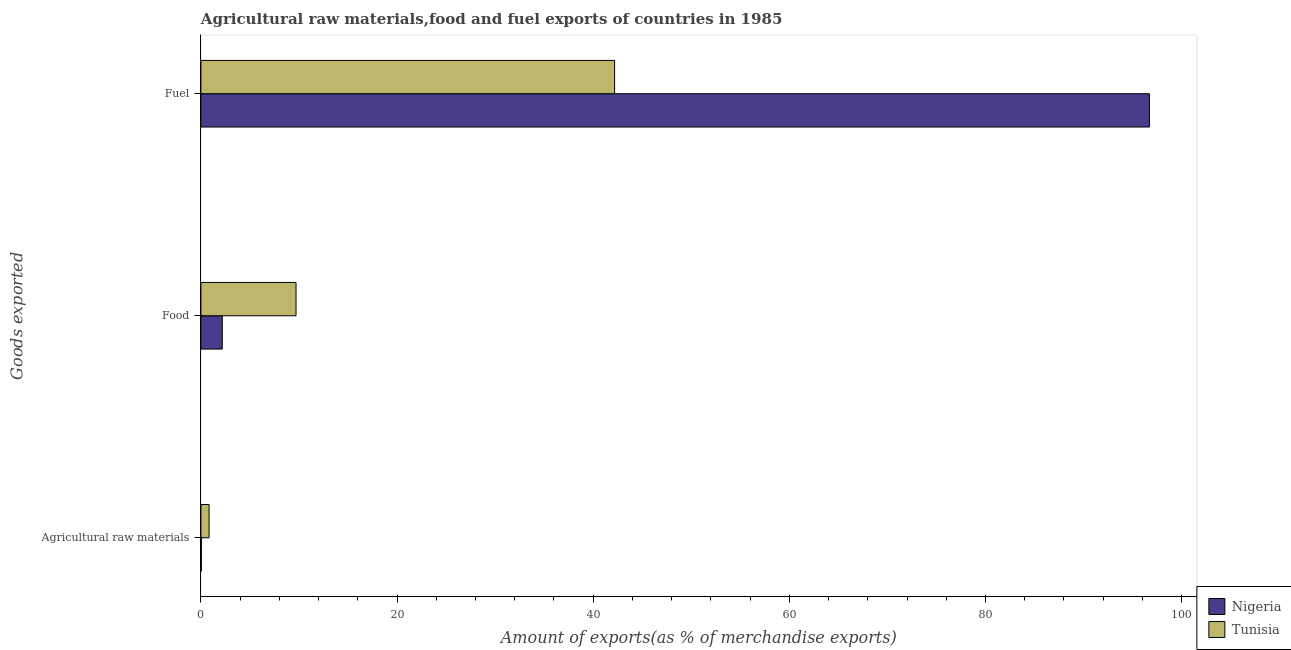How many groups of bars are there?
Your answer should be very brief. 3. How many bars are there on the 2nd tick from the top?
Your answer should be very brief. 2. How many bars are there on the 3rd tick from the bottom?
Provide a short and direct response. 2. What is the label of the 2nd group of bars from the top?
Provide a succinct answer. Food. What is the percentage of fuel exports in Nigeria?
Offer a terse response. 96.72. Across all countries, what is the maximum percentage of raw materials exports?
Offer a very short reply. 0.83. Across all countries, what is the minimum percentage of raw materials exports?
Offer a terse response. 0.04. In which country was the percentage of fuel exports maximum?
Your answer should be very brief. Nigeria. In which country was the percentage of food exports minimum?
Provide a succinct answer. Nigeria. What is the total percentage of food exports in the graph?
Offer a terse response. 11.88. What is the difference between the percentage of food exports in Tunisia and that in Nigeria?
Offer a terse response. 7.52. What is the difference between the percentage of fuel exports in Nigeria and the percentage of raw materials exports in Tunisia?
Provide a short and direct response. 95.89. What is the average percentage of food exports per country?
Your answer should be compact. 5.94. What is the difference between the percentage of raw materials exports and percentage of food exports in Nigeria?
Your answer should be very brief. -2.13. What is the ratio of the percentage of fuel exports in Tunisia to that in Nigeria?
Provide a succinct answer. 0.44. What is the difference between the highest and the second highest percentage of fuel exports?
Provide a succinct answer. 54.53. What is the difference between the highest and the lowest percentage of raw materials exports?
Your answer should be compact. 0.79. In how many countries, is the percentage of food exports greater than the average percentage of food exports taken over all countries?
Your answer should be very brief. 1. Is the sum of the percentage of raw materials exports in Nigeria and Tunisia greater than the maximum percentage of food exports across all countries?
Keep it short and to the point. No. What does the 1st bar from the top in Agricultural raw materials represents?
Ensure brevity in your answer.  Tunisia. What does the 2nd bar from the bottom in Fuel represents?
Ensure brevity in your answer.  Tunisia. Is it the case that in every country, the sum of the percentage of raw materials exports and percentage of food exports is greater than the percentage of fuel exports?
Your answer should be very brief. No. Does the graph contain any zero values?
Your answer should be very brief. No. Does the graph contain grids?
Your response must be concise. No. How many legend labels are there?
Your answer should be compact. 2. How are the legend labels stacked?
Keep it short and to the point. Vertical. What is the title of the graph?
Keep it short and to the point. Agricultural raw materials,food and fuel exports of countries in 1985. What is the label or title of the X-axis?
Keep it short and to the point. Amount of exports(as % of merchandise exports). What is the label or title of the Y-axis?
Provide a short and direct response. Goods exported. What is the Amount of exports(as % of merchandise exports) in Nigeria in Agricultural raw materials?
Give a very brief answer. 0.04. What is the Amount of exports(as % of merchandise exports) of Tunisia in Agricultural raw materials?
Give a very brief answer. 0.83. What is the Amount of exports(as % of merchandise exports) in Nigeria in Food?
Make the answer very short. 2.18. What is the Amount of exports(as % of merchandise exports) in Tunisia in Food?
Your answer should be compact. 9.7. What is the Amount of exports(as % of merchandise exports) in Nigeria in Fuel?
Your answer should be very brief. 96.72. What is the Amount of exports(as % of merchandise exports) of Tunisia in Fuel?
Your answer should be compact. 42.18. Across all Goods exported, what is the maximum Amount of exports(as % of merchandise exports) of Nigeria?
Your answer should be very brief. 96.72. Across all Goods exported, what is the maximum Amount of exports(as % of merchandise exports) of Tunisia?
Your answer should be compact. 42.18. Across all Goods exported, what is the minimum Amount of exports(as % of merchandise exports) of Nigeria?
Ensure brevity in your answer.  0.04. Across all Goods exported, what is the minimum Amount of exports(as % of merchandise exports) in Tunisia?
Offer a very short reply. 0.83. What is the total Amount of exports(as % of merchandise exports) of Nigeria in the graph?
Provide a short and direct response. 98.94. What is the total Amount of exports(as % of merchandise exports) in Tunisia in the graph?
Offer a terse response. 52.71. What is the difference between the Amount of exports(as % of merchandise exports) of Nigeria in Agricultural raw materials and that in Food?
Provide a succinct answer. -2.13. What is the difference between the Amount of exports(as % of merchandise exports) of Tunisia in Agricultural raw materials and that in Food?
Offer a very short reply. -8.87. What is the difference between the Amount of exports(as % of merchandise exports) of Nigeria in Agricultural raw materials and that in Fuel?
Give a very brief answer. -96.67. What is the difference between the Amount of exports(as % of merchandise exports) of Tunisia in Agricultural raw materials and that in Fuel?
Keep it short and to the point. -41.35. What is the difference between the Amount of exports(as % of merchandise exports) in Nigeria in Food and that in Fuel?
Provide a succinct answer. -94.54. What is the difference between the Amount of exports(as % of merchandise exports) in Tunisia in Food and that in Fuel?
Your answer should be very brief. -32.48. What is the difference between the Amount of exports(as % of merchandise exports) of Nigeria in Agricultural raw materials and the Amount of exports(as % of merchandise exports) of Tunisia in Food?
Your answer should be compact. -9.65. What is the difference between the Amount of exports(as % of merchandise exports) of Nigeria in Agricultural raw materials and the Amount of exports(as % of merchandise exports) of Tunisia in Fuel?
Your response must be concise. -42.14. What is the difference between the Amount of exports(as % of merchandise exports) of Nigeria in Food and the Amount of exports(as % of merchandise exports) of Tunisia in Fuel?
Offer a terse response. -40.01. What is the average Amount of exports(as % of merchandise exports) of Nigeria per Goods exported?
Keep it short and to the point. 32.98. What is the average Amount of exports(as % of merchandise exports) of Tunisia per Goods exported?
Give a very brief answer. 17.57. What is the difference between the Amount of exports(as % of merchandise exports) of Nigeria and Amount of exports(as % of merchandise exports) of Tunisia in Agricultural raw materials?
Provide a short and direct response. -0.79. What is the difference between the Amount of exports(as % of merchandise exports) in Nigeria and Amount of exports(as % of merchandise exports) in Tunisia in Food?
Offer a very short reply. -7.52. What is the difference between the Amount of exports(as % of merchandise exports) in Nigeria and Amount of exports(as % of merchandise exports) in Tunisia in Fuel?
Ensure brevity in your answer.  54.53. What is the ratio of the Amount of exports(as % of merchandise exports) of Nigeria in Agricultural raw materials to that in Food?
Give a very brief answer. 0.02. What is the ratio of the Amount of exports(as % of merchandise exports) in Tunisia in Agricultural raw materials to that in Food?
Offer a very short reply. 0.09. What is the ratio of the Amount of exports(as % of merchandise exports) in Nigeria in Agricultural raw materials to that in Fuel?
Give a very brief answer. 0. What is the ratio of the Amount of exports(as % of merchandise exports) in Tunisia in Agricultural raw materials to that in Fuel?
Your answer should be compact. 0.02. What is the ratio of the Amount of exports(as % of merchandise exports) of Nigeria in Food to that in Fuel?
Offer a very short reply. 0.02. What is the ratio of the Amount of exports(as % of merchandise exports) in Tunisia in Food to that in Fuel?
Provide a succinct answer. 0.23. What is the difference between the highest and the second highest Amount of exports(as % of merchandise exports) of Nigeria?
Your response must be concise. 94.54. What is the difference between the highest and the second highest Amount of exports(as % of merchandise exports) in Tunisia?
Offer a terse response. 32.48. What is the difference between the highest and the lowest Amount of exports(as % of merchandise exports) in Nigeria?
Keep it short and to the point. 96.67. What is the difference between the highest and the lowest Amount of exports(as % of merchandise exports) of Tunisia?
Offer a very short reply. 41.35. 